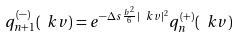<formula> <loc_0><loc_0><loc_500><loc_500>q ^ { ( - ) } _ { n + 1 } ( \ k v ) = e ^ { - \Delta s \frac { b ^ { 2 } } { 6 } | \ k v | ^ { 2 } } q _ { n } ^ { ( + ) } ( \ k v )</formula> 